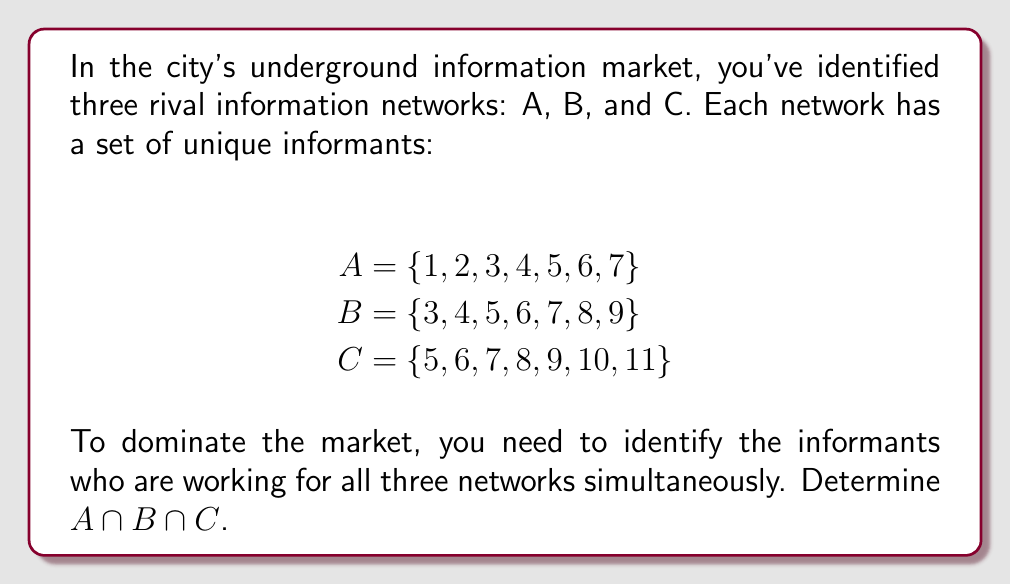Show me your answer to this math problem. To find the intersection of these three sets, we need to identify the elements that are common to all three sets. Let's approach this step-by-step:

1. First, let's find the intersection of A and B:
   $A \cap B = \{3, 4, 5, 6, 7\}$

2. Now, we need to find the intersection of this result with C:
   $(A \cap B) \cap C$

3. We compare the elements in $\{3, 4, 5, 6, 7\}$ with the elements in C:
   C = {5, 6, 7, 8, 9, 10, 11}

4. The elements that appear in both $(A \cap B)$ and C are:
   $\{5, 6, 7\}$

Therefore, $A \cap B \cap C = \{5, 6, 7\}$

This means that informants 5, 6, and 7 are working for all three networks simultaneously.

[asy]
unitsize(1cm);

draw(circle((0,0),2));
draw(circle((2,0),2));
draw(circle((1,-1.5),2));

label("A", (-1.5,1));
label("B", (3.5,1));
label("C", (1,-3));

label("5,6,7", (1,-0.5));

draw((1,-0.5)--(1.8,-0.1),arrow=Arrow(TeXHead));
[/asy]
Answer: $A \cap B \cap C = \{5, 6, 7\}$ 